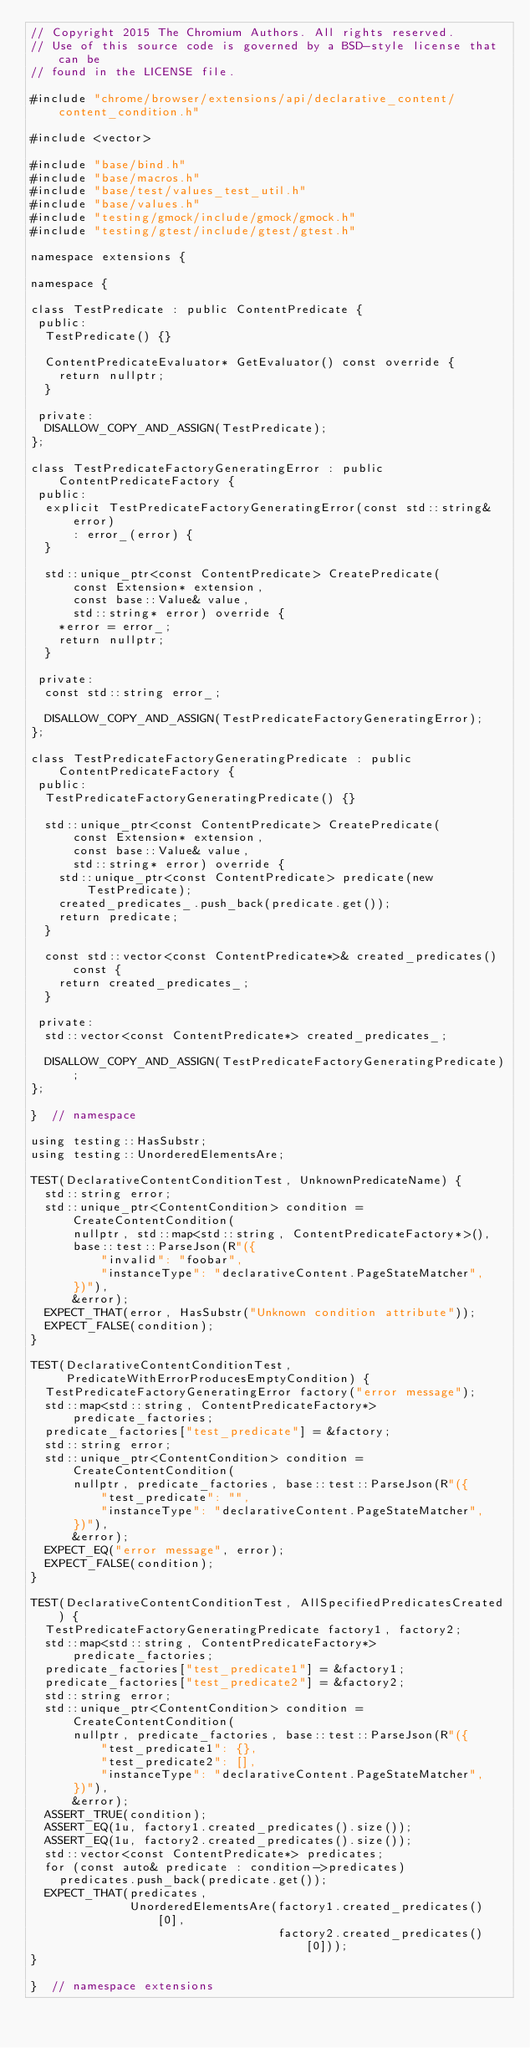<code> <loc_0><loc_0><loc_500><loc_500><_C++_>// Copyright 2015 The Chromium Authors. All rights reserved.
// Use of this source code is governed by a BSD-style license that can be
// found in the LICENSE file.

#include "chrome/browser/extensions/api/declarative_content/content_condition.h"

#include <vector>

#include "base/bind.h"
#include "base/macros.h"
#include "base/test/values_test_util.h"
#include "base/values.h"
#include "testing/gmock/include/gmock/gmock.h"
#include "testing/gtest/include/gtest/gtest.h"

namespace extensions {

namespace {

class TestPredicate : public ContentPredicate {
 public:
  TestPredicate() {}

  ContentPredicateEvaluator* GetEvaluator() const override {
    return nullptr;
  }

 private:
  DISALLOW_COPY_AND_ASSIGN(TestPredicate);
};

class TestPredicateFactoryGeneratingError : public ContentPredicateFactory {
 public:
  explicit TestPredicateFactoryGeneratingError(const std::string& error)
      : error_(error) {
  }

  std::unique_ptr<const ContentPredicate> CreatePredicate(
      const Extension* extension,
      const base::Value& value,
      std::string* error) override {
    *error = error_;
    return nullptr;
  }

 private:
  const std::string error_;

  DISALLOW_COPY_AND_ASSIGN(TestPredicateFactoryGeneratingError);
};

class TestPredicateFactoryGeneratingPredicate : public ContentPredicateFactory {
 public:
  TestPredicateFactoryGeneratingPredicate() {}

  std::unique_ptr<const ContentPredicate> CreatePredicate(
      const Extension* extension,
      const base::Value& value,
      std::string* error) override {
    std::unique_ptr<const ContentPredicate> predicate(new TestPredicate);
    created_predicates_.push_back(predicate.get());
    return predicate;
  }

  const std::vector<const ContentPredicate*>& created_predicates() const {
    return created_predicates_;
  }

 private:
  std::vector<const ContentPredicate*> created_predicates_;

  DISALLOW_COPY_AND_ASSIGN(TestPredicateFactoryGeneratingPredicate);
};

}  // namespace

using testing::HasSubstr;
using testing::UnorderedElementsAre;

TEST(DeclarativeContentConditionTest, UnknownPredicateName) {
  std::string error;
  std::unique_ptr<ContentCondition> condition = CreateContentCondition(
      nullptr, std::map<std::string, ContentPredicateFactory*>(),
      base::test::ParseJson(R"({
          "invalid": "foobar",
          "instanceType": "declarativeContent.PageStateMatcher",
      })"),
      &error);
  EXPECT_THAT(error, HasSubstr("Unknown condition attribute"));
  EXPECT_FALSE(condition);
}

TEST(DeclarativeContentConditionTest,
     PredicateWithErrorProducesEmptyCondition) {
  TestPredicateFactoryGeneratingError factory("error message");
  std::map<std::string, ContentPredicateFactory*> predicate_factories;
  predicate_factories["test_predicate"] = &factory;
  std::string error;
  std::unique_ptr<ContentCondition> condition = CreateContentCondition(
      nullptr, predicate_factories, base::test::ParseJson(R"({
          "test_predicate": "",
          "instanceType": "declarativeContent.PageStateMatcher",
      })"),
      &error);
  EXPECT_EQ("error message", error);
  EXPECT_FALSE(condition);
}

TEST(DeclarativeContentConditionTest, AllSpecifiedPredicatesCreated) {
  TestPredicateFactoryGeneratingPredicate factory1, factory2;
  std::map<std::string, ContentPredicateFactory*> predicate_factories;
  predicate_factories["test_predicate1"] = &factory1;
  predicate_factories["test_predicate2"] = &factory2;
  std::string error;
  std::unique_ptr<ContentCondition> condition = CreateContentCondition(
      nullptr, predicate_factories, base::test::ParseJson(R"({
          "test_predicate1": {},
          "test_predicate2": [],
          "instanceType": "declarativeContent.PageStateMatcher",
      })"),
      &error);
  ASSERT_TRUE(condition);
  ASSERT_EQ(1u, factory1.created_predicates().size());
  ASSERT_EQ(1u, factory2.created_predicates().size());
  std::vector<const ContentPredicate*> predicates;
  for (const auto& predicate : condition->predicates)
    predicates.push_back(predicate.get());
  EXPECT_THAT(predicates,
              UnorderedElementsAre(factory1.created_predicates()[0],
                                   factory2.created_predicates()[0]));
}

}  // namespace extensions
</code> 